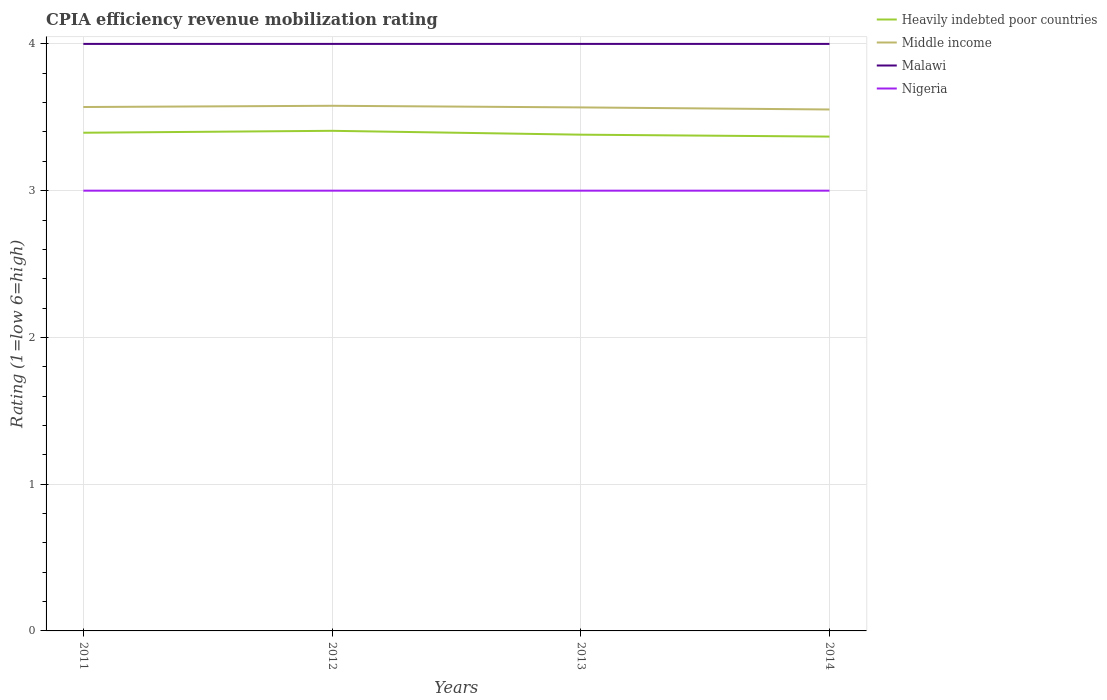Does the line corresponding to Nigeria intersect with the line corresponding to Malawi?
Your answer should be compact. No. Across all years, what is the maximum CPIA rating in Malawi?
Your answer should be very brief. 4. In which year was the CPIA rating in Malawi maximum?
Your answer should be compact. 2011. What is the total CPIA rating in Middle income in the graph?
Your response must be concise. 0.01. What is the difference between the highest and the second highest CPIA rating in Heavily indebted poor countries?
Your answer should be compact. 0.04. Is the CPIA rating in Malawi strictly greater than the CPIA rating in Middle income over the years?
Ensure brevity in your answer.  No. What is the difference between two consecutive major ticks on the Y-axis?
Ensure brevity in your answer.  1. Are the values on the major ticks of Y-axis written in scientific E-notation?
Ensure brevity in your answer.  No. How many legend labels are there?
Your response must be concise. 4. How are the legend labels stacked?
Provide a succinct answer. Vertical. What is the title of the graph?
Your answer should be compact. CPIA efficiency revenue mobilization rating. What is the label or title of the X-axis?
Give a very brief answer. Years. What is the Rating (1=low 6=high) in Heavily indebted poor countries in 2011?
Your answer should be compact. 3.39. What is the Rating (1=low 6=high) of Middle income in 2011?
Offer a very short reply. 3.57. What is the Rating (1=low 6=high) of Malawi in 2011?
Your answer should be compact. 4. What is the Rating (1=low 6=high) of Heavily indebted poor countries in 2012?
Offer a terse response. 3.41. What is the Rating (1=low 6=high) in Middle income in 2012?
Offer a terse response. 3.58. What is the Rating (1=low 6=high) in Nigeria in 2012?
Provide a succinct answer. 3. What is the Rating (1=low 6=high) in Heavily indebted poor countries in 2013?
Keep it short and to the point. 3.38. What is the Rating (1=low 6=high) of Middle income in 2013?
Provide a succinct answer. 3.57. What is the Rating (1=low 6=high) of Malawi in 2013?
Offer a very short reply. 4. What is the Rating (1=low 6=high) in Heavily indebted poor countries in 2014?
Keep it short and to the point. 3.37. What is the Rating (1=low 6=high) of Middle income in 2014?
Make the answer very short. 3.55. What is the Rating (1=low 6=high) in Malawi in 2014?
Your answer should be very brief. 4. Across all years, what is the maximum Rating (1=low 6=high) in Heavily indebted poor countries?
Make the answer very short. 3.41. Across all years, what is the maximum Rating (1=low 6=high) of Middle income?
Keep it short and to the point. 3.58. Across all years, what is the maximum Rating (1=low 6=high) in Malawi?
Keep it short and to the point. 4. Across all years, what is the minimum Rating (1=low 6=high) of Heavily indebted poor countries?
Ensure brevity in your answer.  3.37. Across all years, what is the minimum Rating (1=low 6=high) of Middle income?
Provide a succinct answer. 3.55. Across all years, what is the minimum Rating (1=low 6=high) in Nigeria?
Ensure brevity in your answer.  3. What is the total Rating (1=low 6=high) in Heavily indebted poor countries in the graph?
Keep it short and to the point. 13.55. What is the total Rating (1=low 6=high) in Middle income in the graph?
Give a very brief answer. 14.27. What is the total Rating (1=low 6=high) in Nigeria in the graph?
Provide a succinct answer. 12. What is the difference between the Rating (1=low 6=high) in Heavily indebted poor countries in 2011 and that in 2012?
Keep it short and to the point. -0.01. What is the difference between the Rating (1=low 6=high) in Middle income in 2011 and that in 2012?
Keep it short and to the point. -0.01. What is the difference between the Rating (1=low 6=high) of Nigeria in 2011 and that in 2012?
Your response must be concise. 0. What is the difference between the Rating (1=low 6=high) of Heavily indebted poor countries in 2011 and that in 2013?
Provide a short and direct response. 0.01. What is the difference between the Rating (1=low 6=high) of Middle income in 2011 and that in 2013?
Provide a succinct answer. 0. What is the difference between the Rating (1=low 6=high) of Malawi in 2011 and that in 2013?
Offer a terse response. 0. What is the difference between the Rating (1=low 6=high) in Nigeria in 2011 and that in 2013?
Keep it short and to the point. 0. What is the difference between the Rating (1=low 6=high) in Heavily indebted poor countries in 2011 and that in 2014?
Your answer should be compact. 0.03. What is the difference between the Rating (1=low 6=high) in Middle income in 2011 and that in 2014?
Ensure brevity in your answer.  0.02. What is the difference between the Rating (1=low 6=high) of Malawi in 2011 and that in 2014?
Your response must be concise. 0. What is the difference between the Rating (1=low 6=high) in Nigeria in 2011 and that in 2014?
Your answer should be compact. 0. What is the difference between the Rating (1=low 6=high) in Heavily indebted poor countries in 2012 and that in 2013?
Make the answer very short. 0.03. What is the difference between the Rating (1=low 6=high) of Middle income in 2012 and that in 2013?
Offer a terse response. 0.01. What is the difference between the Rating (1=low 6=high) of Malawi in 2012 and that in 2013?
Give a very brief answer. 0. What is the difference between the Rating (1=low 6=high) in Heavily indebted poor countries in 2012 and that in 2014?
Give a very brief answer. 0.04. What is the difference between the Rating (1=low 6=high) in Middle income in 2012 and that in 2014?
Give a very brief answer. 0.03. What is the difference between the Rating (1=low 6=high) in Heavily indebted poor countries in 2013 and that in 2014?
Your response must be concise. 0.01. What is the difference between the Rating (1=low 6=high) in Middle income in 2013 and that in 2014?
Your answer should be very brief. 0.01. What is the difference between the Rating (1=low 6=high) in Malawi in 2013 and that in 2014?
Your answer should be very brief. 0. What is the difference between the Rating (1=low 6=high) of Nigeria in 2013 and that in 2014?
Offer a very short reply. 0. What is the difference between the Rating (1=low 6=high) of Heavily indebted poor countries in 2011 and the Rating (1=low 6=high) of Middle income in 2012?
Provide a short and direct response. -0.18. What is the difference between the Rating (1=low 6=high) of Heavily indebted poor countries in 2011 and the Rating (1=low 6=high) of Malawi in 2012?
Provide a short and direct response. -0.61. What is the difference between the Rating (1=low 6=high) in Heavily indebted poor countries in 2011 and the Rating (1=low 6=high) in Nigeria in 2012?
Offer a very short reply. 0.39. What is the difference between the Rating (1=low 6=high) in Middle income in 2011 and the Rating (1=low 6=high) in Malawi in 2012?
Offer a terse response. -0.43. What is the difference between the Rating (1=low 6=high) in Middle income in 2011 and the Rating (1=low 6=high) in Nigeria in 2012?
Provide a short and direct response. 0.57. What is the difference between the Rating (1=low 6=high) of Malawi in 2011 and the Rating (1=low 6=high) of Nigeria in 2012?
Provide a succinct answer. 1. What is the difference between the Rating (1=low 6=high) in Heavily indebted poor countries in 2011 and the Rating (1=low 6=high) in Middle income in 2013?
Your answer should be compact. -0.17. What is the difference between the Rating (1=low 6=high) in Heavily indebted poor countries in 2011 and the Rating (1=low 6=high) in Malawi in 2013?
Offer a very short reply. -0.61. What is the difference between the Rating (1=low 6=high) of Heavily indebted poor countries in 2011 and the Rating (1=low 6=high) of Nigeria in 2013?
Ensure brevity in your answer.  0.39. What is the difference between the Rating (1=low 6=high) in Middle income in 2011 and the Rating (1=low 6=high) in Malawi in 2013?
Give a very brief answer. -0.43. What is the difference between the Rating (1=low 6=high) of Middle income in 2011 and the Rating (1=low 6=high) of Nigeria in 2013?
Keep it short and to the point. 0.57. What is the difference between the Rating (1=low 6=high) in Malawi in 2011 and the Rating (1=low 6=high) in Nigeria in 2013?
Provide a short and direct response. 1. What is the difference between the Rating (1=low 6=high) in Heavily indebted poor countries in 2011 and the Rating (1=low 6=high) in Middle income in 2014?
Ensure brevity in your answer.  -0.16. What is the difference between the Rating (1=low 6=high) of Heavily indebted poor countries in 2011 and the Rating (1=low 6=high) of Malawi in 2014?
Make the answer very short. -0.61. What is the difference between the Rating (1=low 6=high) in Heavily indebted poor countries in 2011 and the Rating (1=low 6=high) in Nigeria in 2014?
Keep it short and to the point. 0.39. What is the difference between the Rating (1=low 6=high) of Middle income in 2011 and the Rating (1=low 6=high) of Malawi in 2014?
Offer a very short reply. -0.43. What is the difference between the Rating (1=low 6=high) in Middle income in 2011 and the Rating (1=low 6=high) in Nigeria in 2014?
Your answer should be very brief. 0.57. What is the difference between the Rating (1=low 6=high) of Heavily indebted poor countries in 2012 and the Rating (1=low 6=high) of Middle income in 2013?
Offer a very short reply. -0.16. What is the difference between the Rating (1=low 6=high) in Heavily indebted poor countries in 2012 and the Rating (1=low 6=high) in Malawi in 2013?
Give a very brief answer. -0.59. What is the difference between the Rating (1=low 6=high) of Heavily indebted poor countries in 2012 and the Rating (1=low 6=high) of Nigeria in 2013?
Provide a short and direct response. 0.41. What is the difference between the Rating (1=low 6=high) in Middle income in 2012 and the Rating (1=low 6=high) in Malawi in 2013?
Provide a short and direct response. -0.42. What is the difference between the Rating (1=low 6=high) of Middle income in 2012 and the Rating (1=low 6=high) of Nigeria in 2013?
Provide a short and direct response. 0.58. What is the difference between the Rating (1=low 6=high) in Heavily indebted poor countries in 2012 and the Rating (1=low 6=high) in Middle income in 2014?
Offer a terse response. -0.15. What is the difference between the Rating (1=low 6=high) of Heavily indebted poor countries in 2012 and the Rating (1=low 6=high) of Malawi in 2014?
Offer a terse response. -0.59. What is the difference between the Rating (1=low 6=high) of Heavily indebted poor countries in 2012 and the Rating (1=low 6=high) of Nigeria in 2014?
Offer a terse response. 0.41. What is the difference between the Rating (1=low 6=high) of Middle income in 2012 and the Rating (1=low 6=high) of Malawi in 2014?
Provide a succinct answer. -0.42. What is the difference between the Rating (1=low 6=high) of Middle income in 2012 and the Rating (1=low 6=high) of Nigeria in 2014?
Offer a terse response. 0.58. What is the difference between the Rating (1=low 6=high) of Heavily indebted poor countries in 2013 and the Rating (1=low 6=high) of Middle income in 2014?
Provide a succinct answer. -0.17. What is the difference between the Rating (1=low 6=high) of Heavily indebted poor countries in 2013 and the Rating (1=low 6=high) of Malawi in 2014?
Give a very brief answer. -0.62. What is the difference between the Rating (1=low 6=high) of Heavily indebted poor countries in 2013 and the Rating (1=low 6=high) of Nigeria in 2014?
Keep it short and to the point. 0.38. What is the difference between the Rating (1=low 6=high) in Middle income in 2013 and the Rating (1=low 6=high) in Malawi in 2014?
Offer a terse response. -0.43. What is the difference between the Rating (1=low 6=high) in Middle income in 2013 and the Rating (1=low 6=high) in Nigeria in 2014?
Make the answer very short. 0.57. What is the difference between the Rating (1=low 6=high) of Malawi in 2013 and the Rating (1=low 6=high) of Nigeria in 2014?
Give a very brief answer. 1. What is the average Rating (1=low 6=high) in Heavily indebted poor countries per year?
Your answer should be compact. 3.39. What is the average Rating (1=low 6=high) of Middle income per year?
Offer a very short reply. 3.57. What is the average Rating (1=low 6=high) in Malawi per year?
Ensure brevity in your answer.  4. In the year 2011, what is the difference between the Rating (1=low 6=high) in Heavily indebted poor countries and Rating (1=low 6=high) in Middle income?
Provide a short and direct response. -0.18. In the year 2011, what is the difference between the Rating (1=low 6=high) of Heavily indebted poor countries and Rating (1=low 6=high) of Malawi?
Give a very brief answer. -0.61. In the year 2011, what is the difference between the Rating (1=low 6=high) of Heavily indebted poor countries and Rating (1=low 6=high) of Nigeria?
Your answer should be very brief. 0.39. In the year 2011, what is the difference between the Rating (1=low 6=high) of Middle income and Rating (1=low 6=high) of Malawi?
Ensure brevity in your answer.  -0.43. In the year 2011, what is the difference between the Rating (1=low 6=high) of Middle income and Rating (1=low 6=high) of Nigeria?
Ensure brevity in your answer.  0.57. In the year 2011, what is the difference between the Rating (1=low 6=high) in Malawi and Rating (1=low 6=high) in Nigeria?
Your answer should be very brief. 1. In the year 2012, what is the difference between the Rating (1=low 6=high) of Heavily indebted poor countries and Rating (1=low 6=high) of Middle income?
Make the answer very short. -0.17. In the year 2012, what is the difference between the Rating (1=low 6=high) of Heavily indebted poor countries and Rating (1=low 6=high) of Malawi?
Provide a short and direct response. -0.59. In the year 2012, what is the difference between the Rating (1=low 6=high) in Heavily indebted poor countries and Rating (1=low 6=high) in Nigeria?
Your answer should be very brief. 0.41. In the year 2012, what is the difference between the Rating (1=low 6=high) of Middle income and Rating (1=low 6=high) of Malawi?
Offer a terse response. -0.42. In the year 2012, what is the difference between the Rating (1=low 6=high) of Middle income and Rating (1=low 6=high) of Nigeria?
Offer a terse response. 0.58. In the year 2013, what is the difference between the Rating (1=low 6=high) of Heavily indebted poor countries and Rating (1=low 6=high) of Middle income?
Keep it short and to the point. -0.19. In the year 2013, what is the difference between the Rating (1=low 6=high) in Heavily indebted poor countries and Rating (1=low 6=high) in Malawi?
Offer a very short reply. -0.62. In the year 2013, what is the difference between the Rating (1=low 6=high) in Heavily indebted poor countries and Rating (1=low 6=high) in Nigeria?
Your answer should be compact. 0.38. In the year 2013, what is the difference between the Rating (1=low 6=high) of Middle income and Rating (1=low 6=high) of Malawi?
Your response must be concise. -0.43. In the year 2013, what is the difference between the Rating (1=low 6=high) in Middle income and Rating (1=low 6=high) in Nigeria?
Your answer should be compact. 0.57. In the year 2014, what is the difference between the Rating (1=low 6=high) in Heavily indebted poor countries and Rating (1=low 6=high) in Middle income?
Ensure brevity in your answer.  -0.18. In the year 2014, what is the difference between the Rating (1=low 6=high) in Heavily indebted poor countries and Rating (1=low 6=high) in Malawi?
Offer a terse response. -0.63. In the year 2014, what is the difference between the Rating (1=low 6=high) in Heavily indebted poor countries and Rating (1=low 6=high) in Nigeria?
Give a very brief answer. 0.37. In the year 2014, what is the difference between the Rating (1=low 6=high) in Middle income and Rating (1=low 6=high) in Malawi?
Ensure brevity in your answer.  -0.45. In the year 2014, what is the difference between the Rating (1=low 6=high) in Middle income and Rating (1=low 6=high) in Nigeria?
Provide a short and direct response. 0.55. What is the ratio of the Rating (1=low 6=high) in Heavily indebted poor countries in 2011 to that in 2012?
Your response must be concise. 1. What is the ratio of the Rating (1=low 6=high) in Middle income in 2011 to that in 2012?
Provide a succinct answer. 1. What is the ratio of the Rating (1=low 6=high) of Malawi in 2011 to that in 2012?
Your response must be concise. 1. What is the ratio of the Rating (1=low 6=high) of Nigeria in 2011 to that in 2012?
Offer a terse response. 1. What is the ratio of the Rating (1=low 6=high) of Middle income in 2011 to that in 2014?
Your answer should be compact. 1. What is the ratio of the Rating (1=low 6=high) in Malawi in 2011 to that in 2014?
Make the answer very short. 1. What is the ratio of the Rating (1=low 6=high) of Nigeria in 2011 to that in 2014?
Offer a terse response. 1. What is the ratio of the Rating (1=low 6=high) in Heavily indebted poor countries in 2012 to that in 2013?
Ensure brevity in your answer.  1.01. What is the ratio of the Rating (1=low 6=high) of Nigeria in 2012 to that in 2013?
Provide a short and direct response. 1. What is the ratio of the Rating (1=low 6=high) in Heavily indebted poor countries in 2012 to that in 2014?
Your answer should be very brief. 1.01. What is the ratio of the Rating (1=low 6=high) in Middle income in 2012 to that in 2014?
Provide a short and direct response. 1.01. What is the ratio of the Rating (1=low 6=high) of Malawi in 2012 to that in 2014?
Your response must be concise. 1. What is the ratio of the Rating (1=low 6=high) in Nigeria in 2012 to that in 2014?
Make the answer very short. 1. What is the ratio of the Rating (1=low 6=high) of Malawi in 2013 to that in 2014?
Offer a very short reply. 1. What is the ratio of the Rating (1=low 6=high) of Nigeria in 2013 to that in 2014?
Your answer should be very brief. 1. What is the difference between the highest and the second highest Rating (1=low 6=high) of Heavily indebted poor countries?
Provide a short and direct response. 0.01. What is the difference between the highest and the second highest Rating (1=low 6=high) of Middle income?
Your response must be concise. 0.01. What is the difference between the highest and the second highest Rating (1=low 6=high) in Malawi?
Your answer should be very brief. 0. What is the difference between the highest and the second highest Rating (1=low 6=high) in Nigeria?
Your response must be concise. 0. What is the difference between the highest and the lowest Rating (1=low 6=high) in Heavily indebted poor countries?
Make the answer very short. 0.04. What is the difference between the highest and the lowest Rating (1=low 6=high) of Middle income?
Your response must be concise. 0.03. 